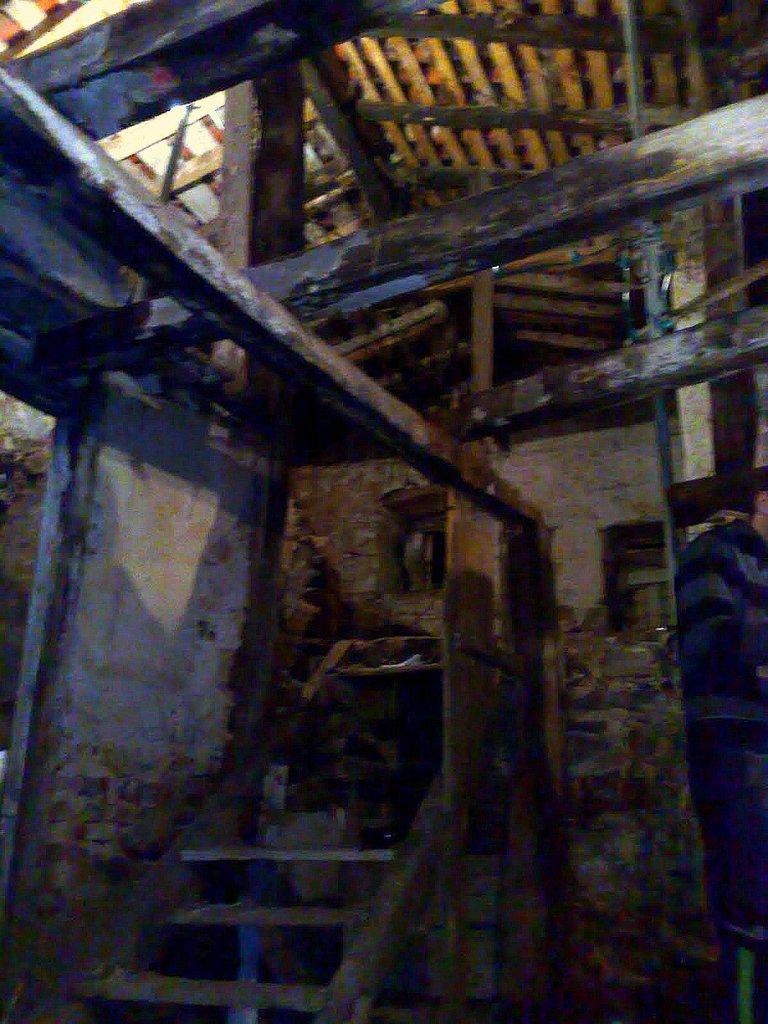What type of structure is visible in the image? There is a house in the image. What architectural feature is present in front of the house? There are steps in front of the house. What is located at the top of the house? There is a roof at the top of the house. Can you describe the person on the right side of the image? There is a person on the right side of the image, but their appearance or actions are not specified. What can be seen in the background of the image? There is a wall in the background of the image. What type of bells can be heard ringing in the image? There are no bells present in the image, and therefore no sound can be heard. 